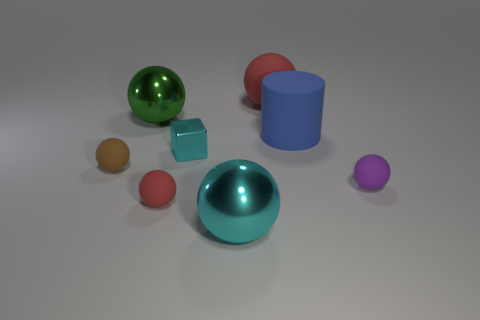Are there any other things that are the same shape as the small shiny thing?
Ensure brevity in your answer.  No. What number of other objects are there of the same material as the big red sphere?
Your response must be concise. 4. What number of rubber things are either large brown balls or large blue objects?
Your response must be concise. 1. Do the big green object left of the cylinder and the purple object have the same shape?
Your response must be concise. Yes. Are there more small cyan things in front of the big blue rubber object than large brown blocks?
Provide a succinct answer. Yes. What number of big spheres are in front of the large green metal thing and behind the purple ball?
Provide a succinct answer. 0. What color is the matte sphere that is to the right of the red rubber ball behind the big blue matte cylinder?
Make the answer very short. Purple. What number of spheres are the same color as the tiny cube?
Give a very brief answer. 1. Do the metal cube and the large shiny thing that is in front of the small brown sphere have the same color?
Provide a succinct answer. Yes. Are there fewer metallic objects than tiny blue shiny cubes?
Your response must be concise. No. 